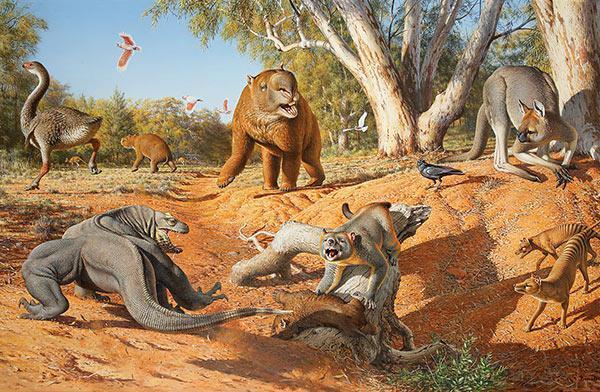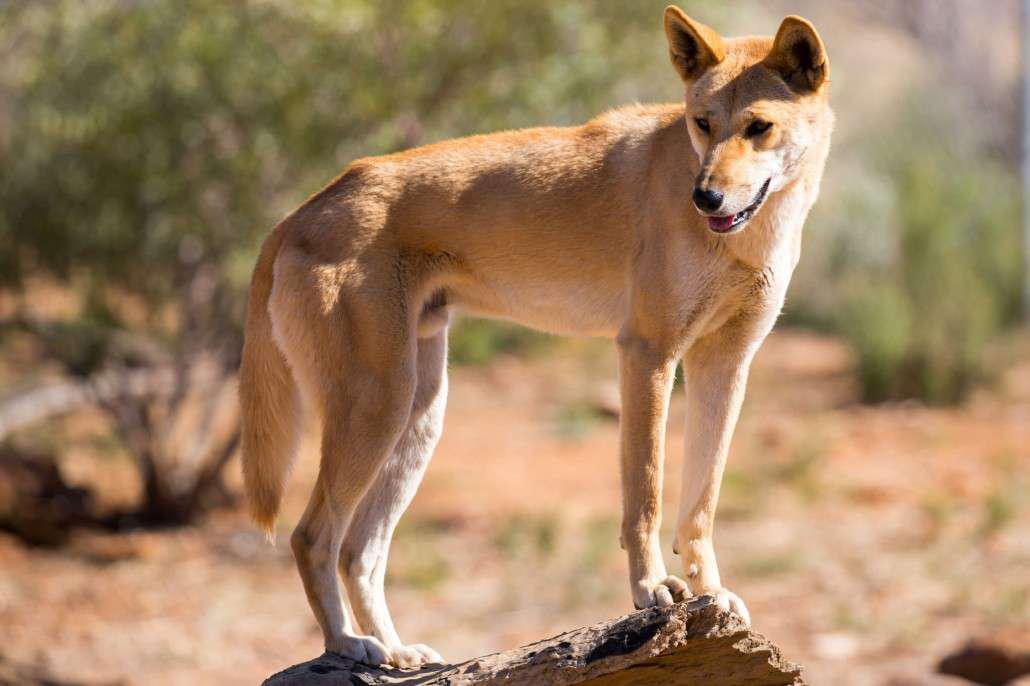The first image is the image on the left, the second image is the image on the right. Evaluate the accuracy of this statement regarding the images: "There are only two dogs and both are looking in different directions.". Is it true? Answer yes or no. No. The first image is the image on the left, the second image is the image on the right. Evaluate the accuracy of this statement regarding the images: "Each photo shows a single dingo in the wild.". Is it true? Answer yes or no. No. 